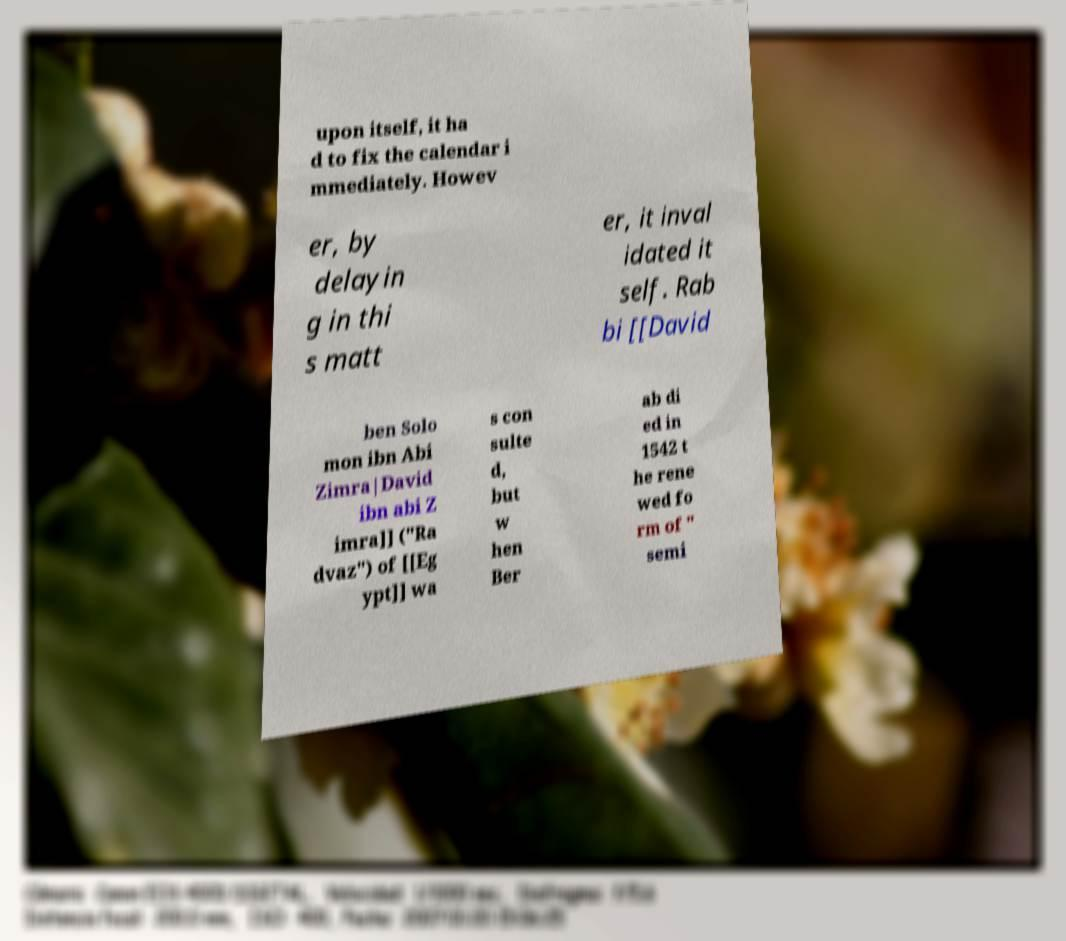Can you accurately transcribe the text from the provided image for me? upon itself, it ha d to fix the calendar i mmediately. Howev er, by delayin g in thi s matt er, it inval idated it self. Rab bi [[David ben Solo mon ibn Abi Zimra|David ibn abi Z imra]] ("Ra dvaz") of [[Eg ypt]] wa s con sulte d, but w hen Ber ab di ed in 1542 t he rene wed fo rm of " semi 